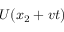Convert formula to latex. <formula><loc_0><loc_0><loc_500><loc_500>U ( x _ { 2 } + v t )</formula> 